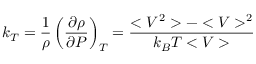Convert formula to latex. <formula><loc_0><loc_0><loc_500><loc_500>k _ { T } = \frac { 1 } { \rho } \left ( \frac { \partial \rho } { \partial P } \right ) _ { T } = \frac { < V ^ { 2 } > - < V > ^ { 2 } } { k _ { B } T < V > }</formula> 